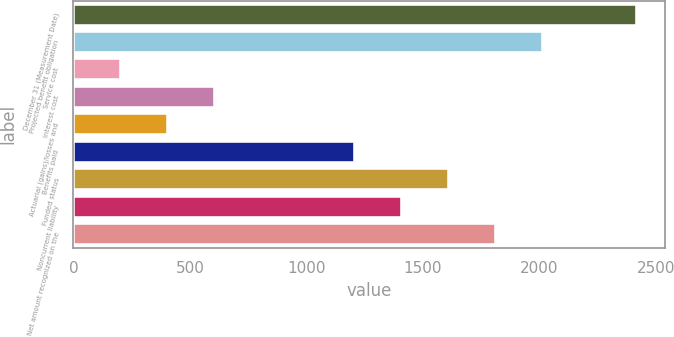Convert chart. <chart><loc_0><loc_0><loc_500><loc_500><bar_chart><fcel>December 31 (Measurement Date)<fcel>Projected benefit obligation<fcel>Service cost<fcel>Interest cost<fcel>Actuarial (gains)/losses and<fcel>Benefits paid<fcel>Funded status<fcel>Noncurrent liability<fcel>Net amount recognized on the<nl><fcel>2417.4<fcel>2015<fcel>204.2<fcel>606.6<fcel>405.4<fcel>1210.2<fcel>1612.6<fcel>1411.4<fcel>1813.8<nl></chart> 